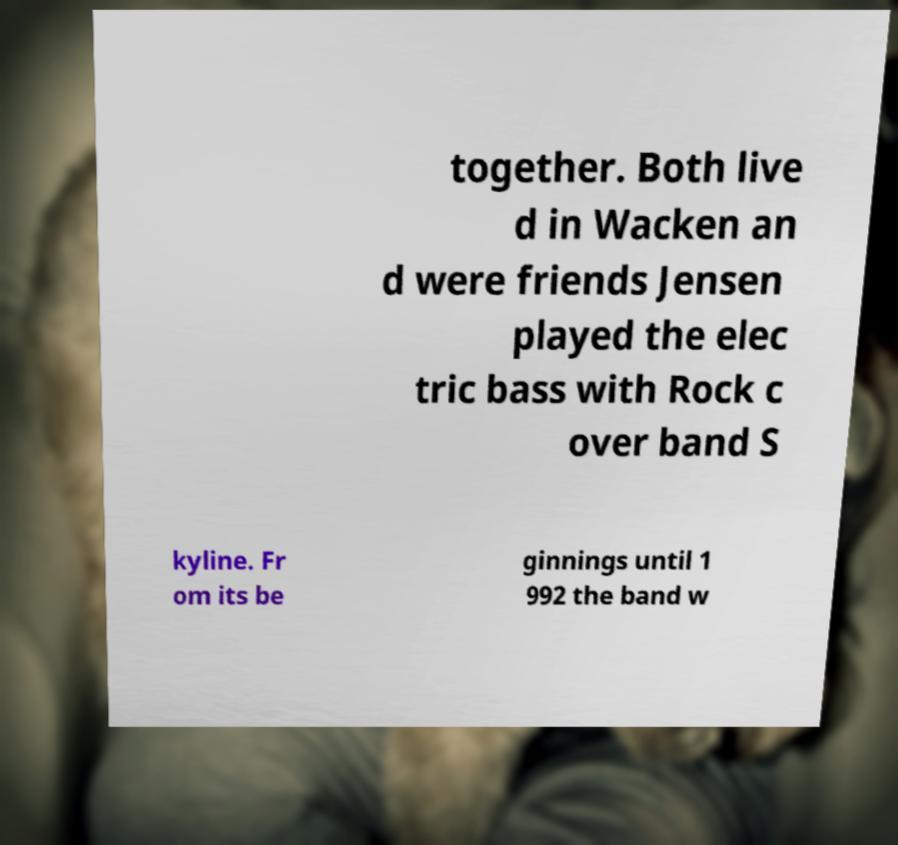I need the written content from this picture converted into text. Can you do that? together. Both live d in Wacken an d were friends Jensen played the elec tric bass with Rock c over band S kyline. Fr om its be ginnings until 1 992 the band w 